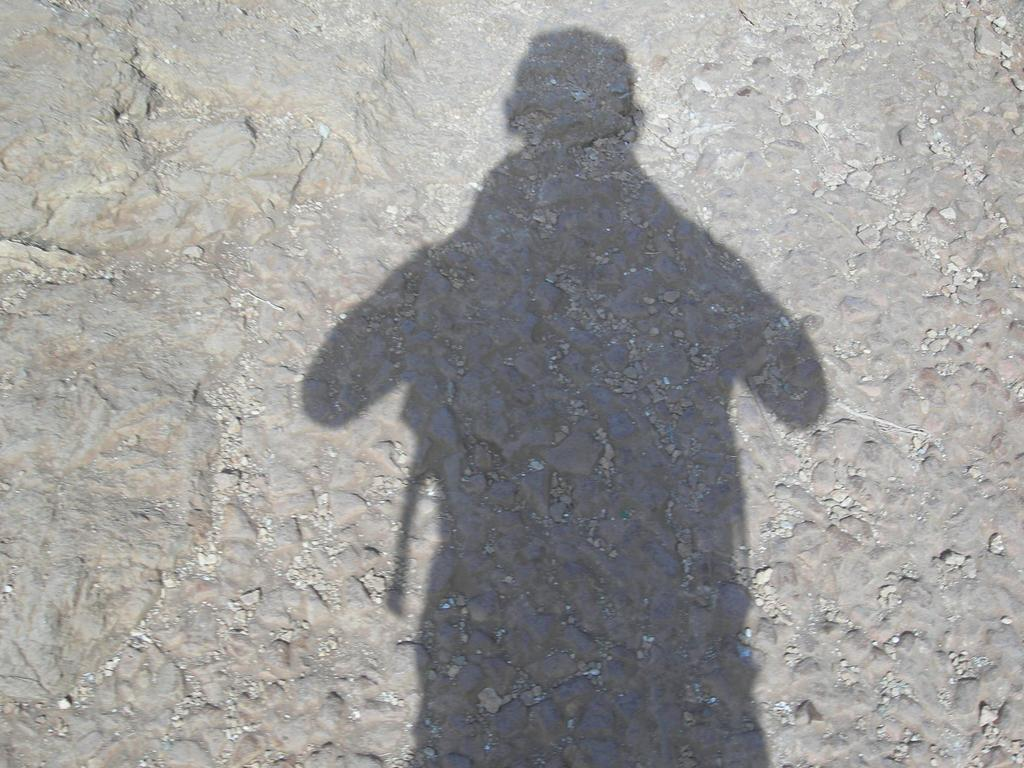What can be seen in the image that suggests the presence of a person? There is a shadow of a person in the image. What type of surface is visible in the image? There is a rock surface in the image. What type of cherry is growing on the rock surface in the image? There is no cherry plant visible on the rock surface in the image. What type of plastic object can be seen in the image? There is no plastic object present in the image. 